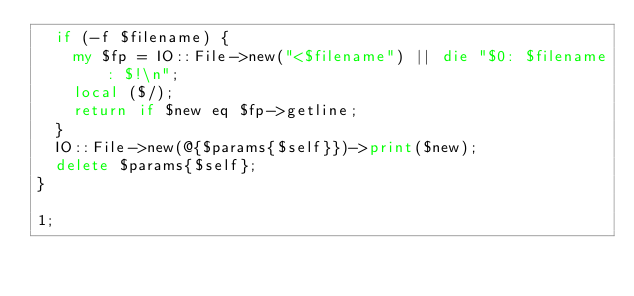<code> <loc_0><loc_0><loc_500><loc_500><_Perl_>	if (-f $filename) {
		my $fp = IO::File->new("<$filename") || die "$0: $filename: $!\n";
		local ($/);
		return if $new eq $fp->getline;
	}
	IO::File->new(@{$params{$self}})->print($new);
	delete $params{$self};
}

1;
</code> 